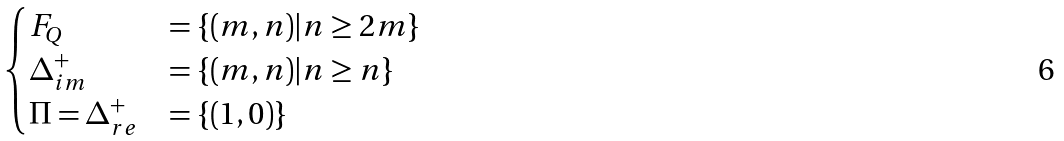<formula> <loc_0><loc_0><loc_500><loc_500>\begin{cases} F _ { Q } & = \{ ( m , n ) | n \geq 2 m \} \\ \Delta _ { i m } ^ { + } & = \{ ( m , n ) | n \geq n \} \\ \Pi = \Delta _ { r e } ^ { + } & = \{ ( 1 , 0 ) \} \end{cases}</formula> 